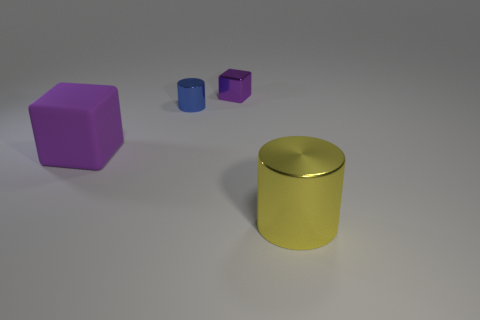Add 2 tiny purple matte balls. How many objects exist? 6 Add 3 tiny cylinders. How many tiny cylinders are left? 4 Add 3 tiny blue shiny cylinders. How many tiny blue shiny cylinders exist? 4 Subtract 1 yellow cylinders. How many objects are left? 3 Subtract all large red cylinders. Subtract all large yellow objects. How many objects are left? 3 